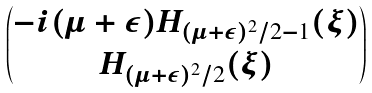Convert formula to latex. <formula><loc_0><loc_0><loc_500><loc_500>\begin{pmatrix} - i ( \mu + \varepsilon ) H _ { ( \mu + \varepsilon ) ^ { 2 } / 2 - 1 } ( \xi ) \\ H _ { ( \mu + \varepsilon ) ^ { 2 } / 2 } ( \xi ) \end{pmatrix}</formula> 